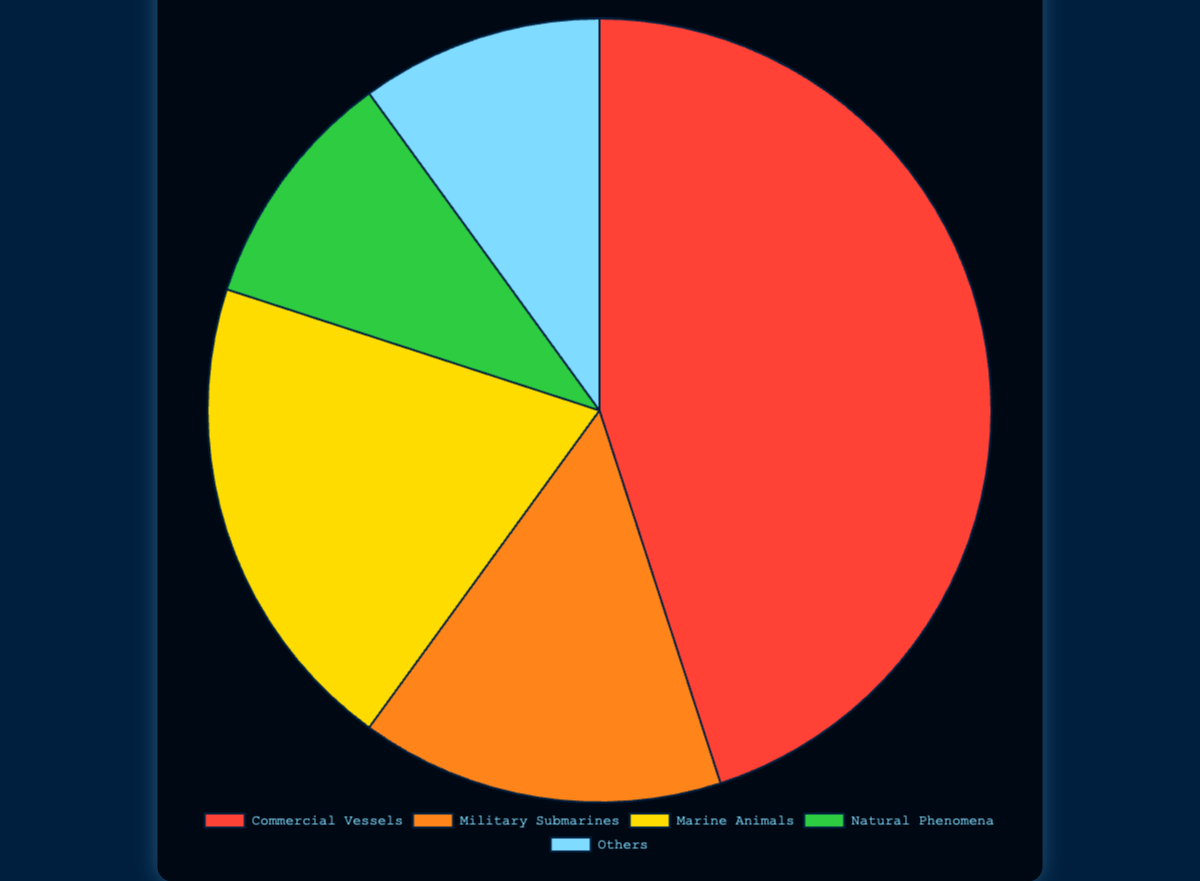What is the most frequently detected sonar signal type? The pie chart shows the distribution of different sonar signal types. By looking at the section with the largest area/size, we can see that Commercial Vessels have the highest frequency.
Answer: Commercial Vessels Which signal type has the smallest frequency? By examining the smallest section of the pie chart, we can identify that both Natural Phenomena and Others have the smallest frequency, each occupying 10%.
Answer: Natural Phenomena and Others How much more frequent are Commercial Vessels compared to Military Submarines? The frequency of Commercial Vessels is 45, and for Military Submarines, it is 15. Subtracting the frequency of Military Submarines from Commercial Vessels gives us the difference: 45 - 15 = 30.
Answer: 30 What percentage of the total frequency is represented by Marine Animals? The frequency for Marine Animals is 20 out of a total of 100 (sum of all frequencies is 45+15+20+10+10=100). Thus, the percentage is calculated as (20/100)*100, which is 20%.
Answer: 20% If you combine the frequencies of Natural Phenomena and Others, what percentage of the total does this combined frequency represent? The frequency for Natural Phenomena (10) and Others (10) sums to 20. The total frequency is 100, so the combined percentage is (20/100)*100 = 20%.
Answer: 20% What is the ratio of the frequency of Commercial Vessels to Marine Animals? The frequency of Commercial Vessels is 45 and that of Marine Animals is 20. Thus, the ratio is 45:20, which simplifies to 9:4 when divided by their greatest common divisor, 5.
Answer: 9:4 Which sonar signal type is represented by the color red in the chart? By checking the color coding of the pie chart, the red section corresponds to Commercial Vessels.
Answer: Commercial Vessels What is the combined frequency of Military Submarines and Marine Animals? The frequency of Military Submarines is 15 and Marine Animals is 20. Adding them gives 15 + 20 = 35.
Answer: 35 How does the frequency of Marine Animals compare to that of Natural Phenomena and Others combined? The frequency of Marine Animals is 20. Natural Phenomena and Others together have a frequency of 10 + 10 = 20. Therefore, Marine Animals have the same frequency as the combined Natural Phenomena and Others.
Answer: Equal What is the average frequency of all sonar signal types? The total frequency is the sum of all individual frequencies, which is 45 + 15 + 20 + 10 + 10 = 100. There are 5 sonar signal types, so the average is 100 / 5 = 20.
Answer: 20 